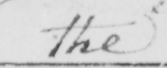What text is written in this handwritten line? the 